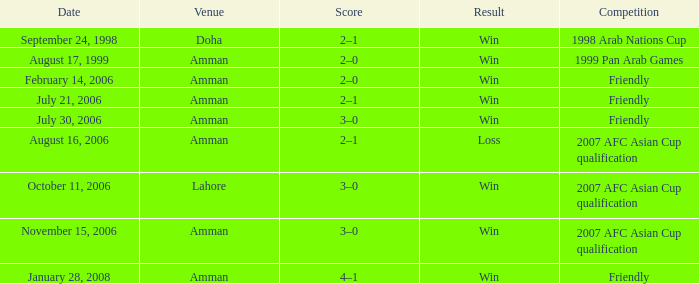Which rivalry happened on october 11, 2006? 2007 AFC Asian Cup qualification. Parse the table in full. {'header': ['Date', 'Venue', 'Score', 'Result', 'Competition'], 'rows': [['September 24, 1998', 'Doha', '2–1', 'Win', '1998 Arab Nations Cup'], ['August 17, 1999', 'Amman', '2–0', 'Win', '1999 Pan Arab Games'], ['February 14, 2006', 'Amman', '2–0', 'Win', 'Friendly'], ['July 21, 2006', 'Amman', '2–1', 'Win', 'Friendly'], ['July 30, 2006', 'Amman', '3–0', 'Win', 'Friendly'], ['August 16, 2006', 'Amman', '2–1', 'Loss', '2007 AFC Asian Cup qualification'], ['October 11, 2006', 'Lahore', '3–0', 'Win', '2007 AFC Asian Cup qualification'], ['November 15, 2006', 'Amman', '3–0', 'Win', '2007 AFC Asian Cup qualification'], ['January 28, 2008', 'Amman', '4–1', 'Win', 'Friendly']]} 